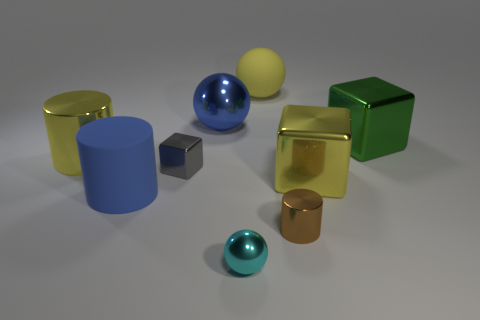Subtract all big metal cylinders. How many cylinders are left? 2 Subtract all green cubes. How many cubes are left? 2 Subtract all yellow balls. Subtract all tiny brown cylinders. How many objects are left? 7 Add 1 large blue balls. How many large blue balls are left? 2 Add 6 large yellow cylinders. How many large yellow cylinders exist? 7 Add 1 tiny spheres. How many objects exist? 10 Subtract 0 red blocks. How many objects are left? 9 Subtract all balls. How many objects are left? 6 Subtract 1 cylinders. How many cylinders are left? 2 Subtract all brown blocks. Subtract all gray spheres. How many blocks are left? 3 